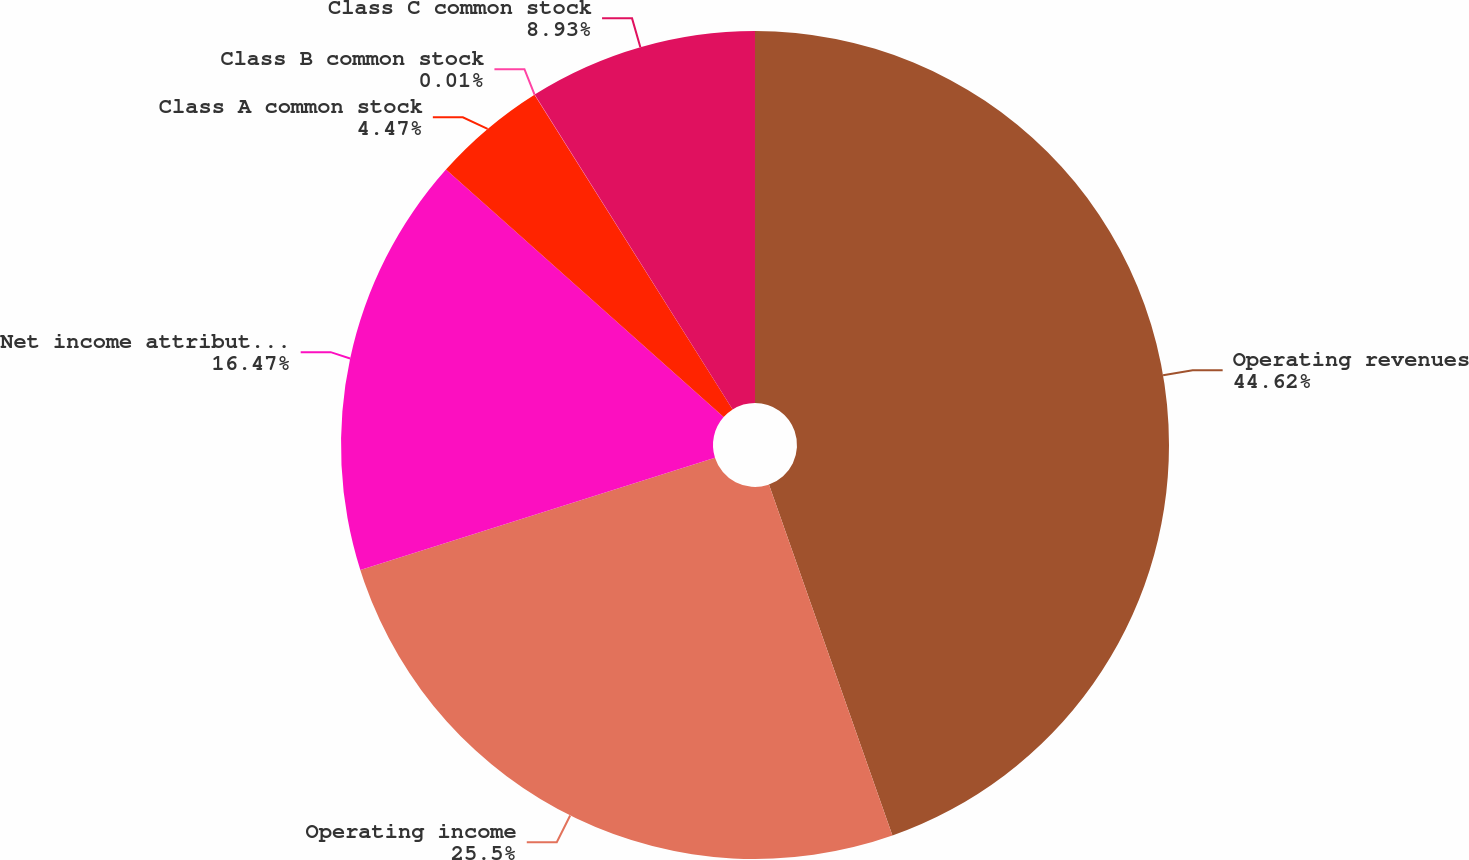Convert chart to OTSL. <chart><loc_0><loc_0><loc_500><loc_500><pie_chart><fcel>Operating revenues<fcel>Operating income<fcel>Net income attributable to<fcel>Class A common stock<fcel>Class B common stock<fcel>Class C common stock<nl><fcel>44.61%<fcel>25.5%<fcel>16.47%<fcel>4.47%<fcel>0.01%<fcel>8.93%<nl></chart> 